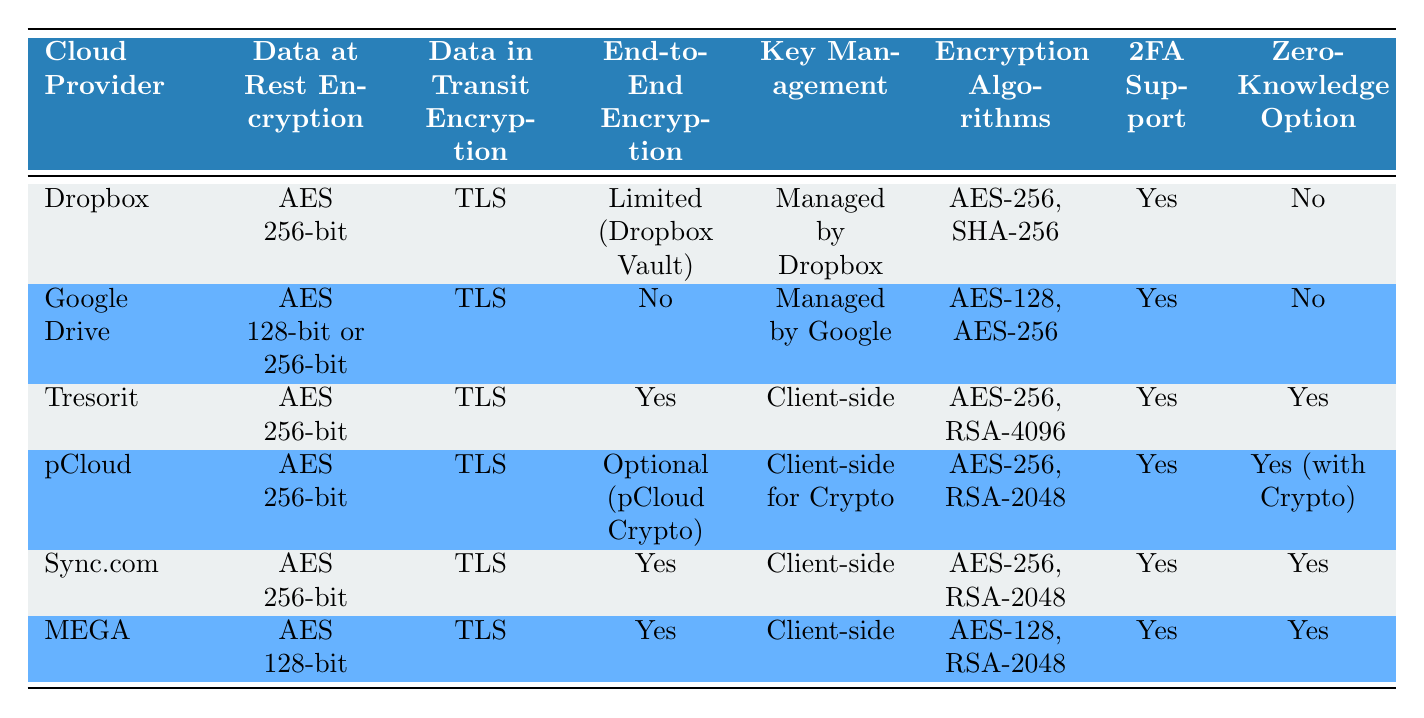What encryption method does Google Drive use for data at rest? According to the table, Google Drive uses either AES 128-bit or 256-bit for data at rest encryption.
Answer: AES 128-bit or 256-bit Which cloud provider offers end-to-end encryption? The table shows that Tresorit, pCloud, Sync.com, and MEGA provide end-to-end encryption.
Answer: Tresorit, pCloud, Sync.com, MEGA What is the key management type for Dropbox? The table indicates that Dropbox manages key management, meaning it is not client-side but rather managed by Dropbox itself.
Answer: Managed by Dropbox How many providers offer a zero-knowledge option? By counting the entries in the Zero-Knowledge Option column, Tresorit, pCloud, Sync.com, and MEGA have a "Yes" under this category, giving a total of four.
Answer: 4 Does pCloud support two-factor authentication? The table shows that pCloud supports two-factor authentication as indicated by the "Yes" under the 2FA Support column.
Answer: Yes Which cloud provider has the most robust encryption algorithm based on the table? Tresorit uses AES-256 with RSA-4096, which is the strongest combination listed in the Encryption Algorithms column.
Answer: Tresorit Are there any providers that offer both client-side key management and a zero-knowledge option? The table indicates that Tresorit, pCloud, and Sync.com offer both client-side key management and a zero-knowledge option, meaning they give users full control over their encryption keys and data privacy.
Answer: Tresorit, pCloud, Sync.com What percentage of the providers listed offer "Yes" for end-to-end encryption? Out of the six providers, four offer end-to-end encryption. Therefore, the percentage is (4/6) * 100 = 66.67%.
Answer: 66.67% Which cloud provider offers the least secure data at rest encryption according to the table? MEGA uses AES 128-bit for data at rest, which is generally considered less secure than AES 256-bit used by others. Therefore, MEGA has the least secure encryption.
Answer: MEGA 